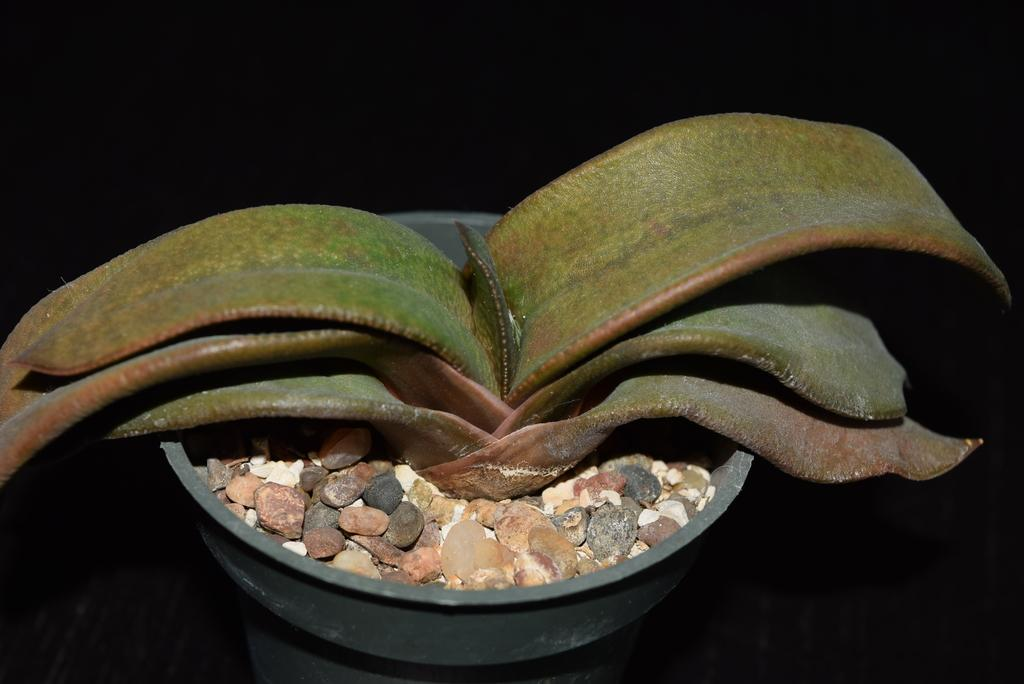What is the main object in the image? There is a plant in a pot in the image. Are there any additional elements associated with the plant or pot? Yes, there are stones placed on the surface of the pot. What type of mitten is the daughter wearing in the image? There is no daughter or mitten present in the image; it only features a plant in a pot with stones on the surface. 